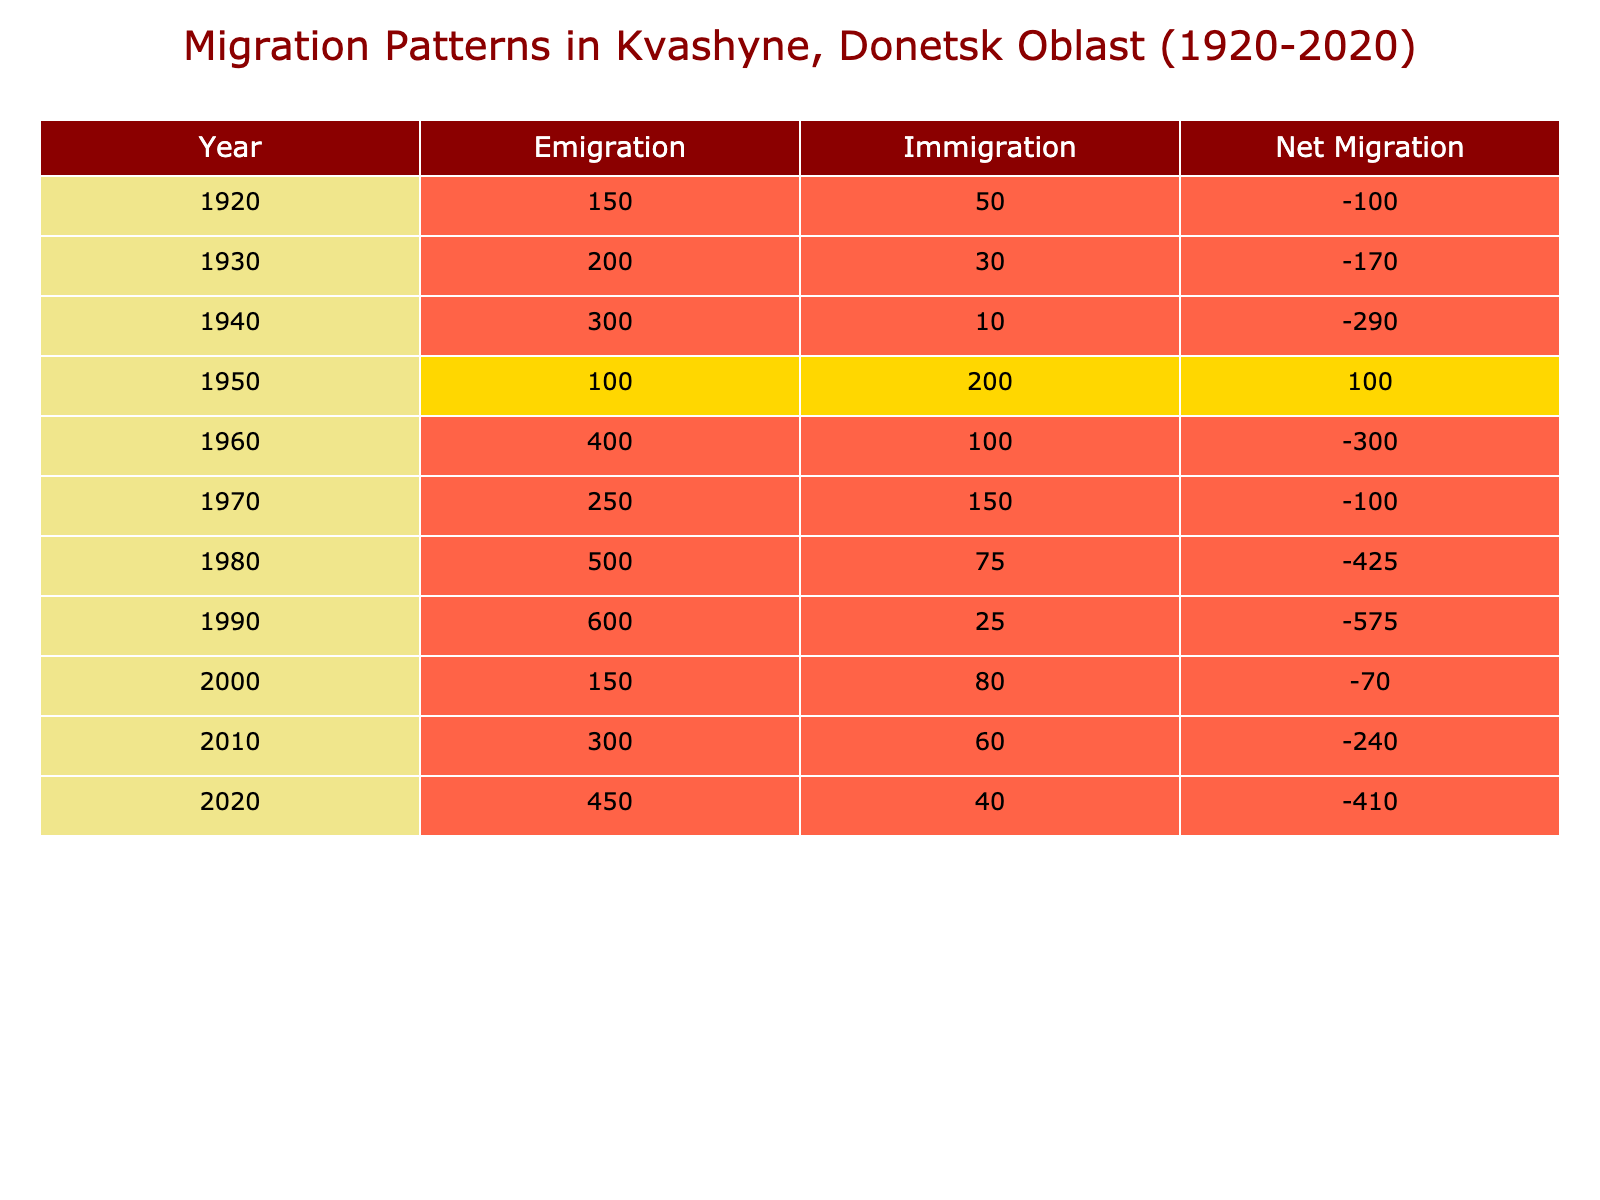What was the highest number of people emigrating in a single year? Referring to the table, the year 1990 shows an emigration number of 600, which is the highest compared to other years listed.
Answer: 600 In which year was the net migration the highest? To find the net migration, subtract the emigration from immigration for each year. Calculating this shows that in 1950, the net migration is 100 (200 - 100), which is the highest compared to other years.
Answer: 1950 How many people immigrated to Kvashyne in 1980? Looking at the table, the number of people who immigrated in 1980 is directly listed as 75.
Answer: 75 Was there more emigration than immigration in the year 1960? For the year 1960, emigration was 400 while immigration was only 100. Since 400 is greater than 100, this statement is true.
Answer: Yes What is the total number of people who immigrated to Kvashyne from 1920 to 2020? By adding the immigration numbers from each year: 50 + 30 + 10 + 200 + 100 + 150 + 75 + 25 + 80 + 60 + 40, the total is 820.
Answer: 820 Which decade had the highest overall emigration? By analyzing the data, the decade from 1980 to 1990 shows the highest cumulative emigration: (500 + 600) = 1100. Other decades do not exceed this amount.
Answer: 1980s What was the total net migration for all years combined? By calculating the total emigration (2980) and total immigration (820), the net migration is: 820 (total immigration) - 2980 (total emigration) = -2160.
Answer: -2160 How many years experienced a net positive migration? From calculating net migration values year by year, net positive migration occurred in 1950 and 1970, resulting in 2 years with positive net migration.
Answer: 2 What was the change in immigration from 2000 to 2010? The number of immigrants in 2000 was 80 and in 2010 it was 60. The change is 60 - 80 = -20, indicating a decrease of 20 people in immigration during that period.
Answer: -20 